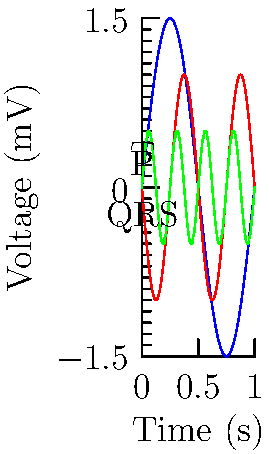Analyze the ECG waveform shown above. Which of the following abnormalities is most likely represented by the red curve?

A) Atrial fibrillation
B) Ventricular tachycardia
C) Second-degree AV block
D) Bundle branch block To interpret this ECG waveform, let's analyze it step-by-step:

1. The blue curve represents the P wave, which is normal in appearance.

2. The red curve represents the QRS complex. It is wider and more prominent than usual, which is a key observation.

3. The green curve represents the T wave, which appears normal.

4. The QRS complex (red curve) shows:
   a) Increased width (duration > 120 ms)
   b) Abnormal morphology (not the typical sharp, narrow complex)

5. These characteristics of the QRS complex are consistent with a conduction delay in the ventricles.

6. Among the given options, bundle branch block is characterized by:
   a) Wide QRS complex (> 120 ms)
   b) Abnormal QRS morphology
   c) Normal P waves and PR interval

7. The other options can be ruled out:
   a) Atrial fibrillation would show irregular rhythm and absence of P waves
   b) Ventricular tachycardia would show a much faster heart rate and even wider QRS complexes
   c) Second-degree AV block would show intermittent non-conducted P waves

Therefore, the abnormality most likely represented by the red curve is a bundle branch block.
Answer: Bundle branch block 